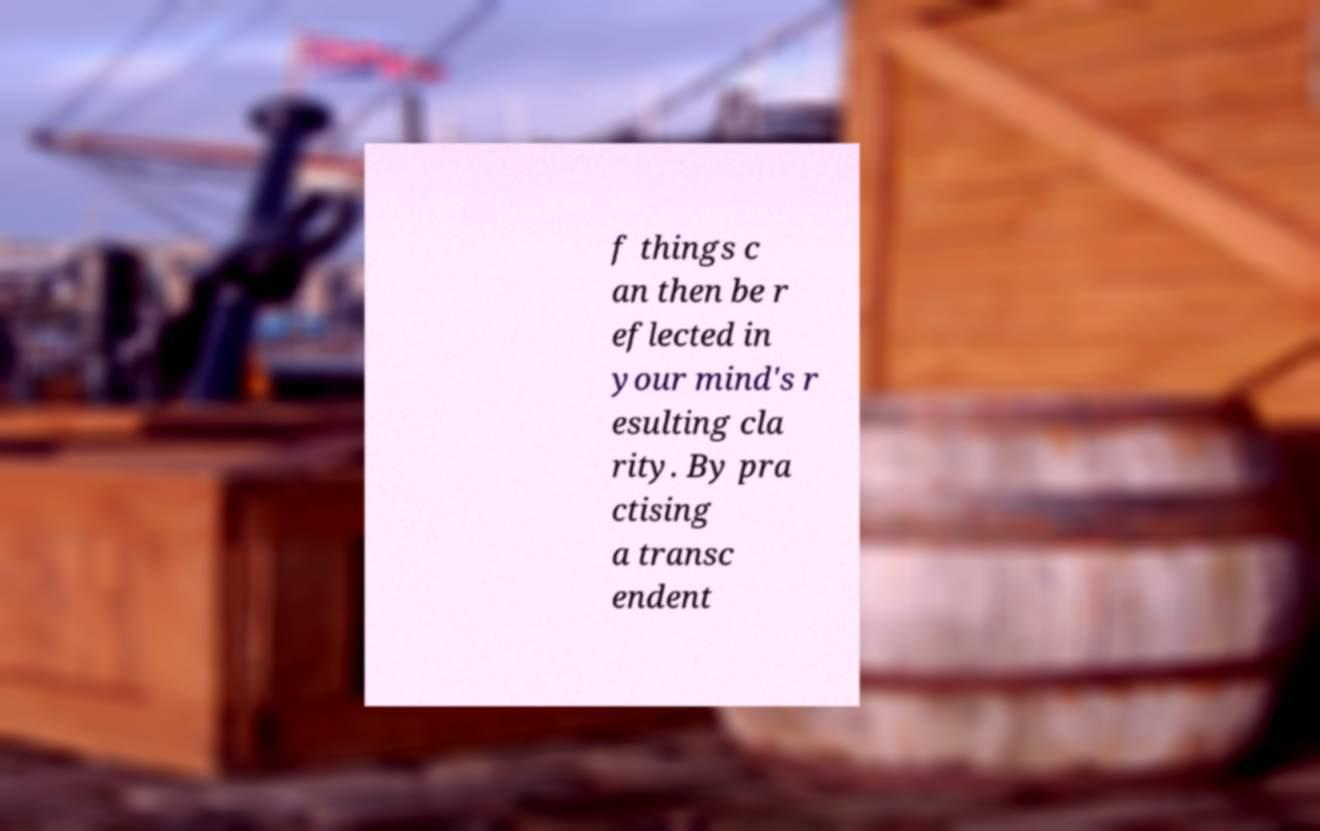I need the written content from this picture converted into text. Can you do that? f things c an then be r eflected in your mind's r esulting cla rity. By pra ctising a transc endent 